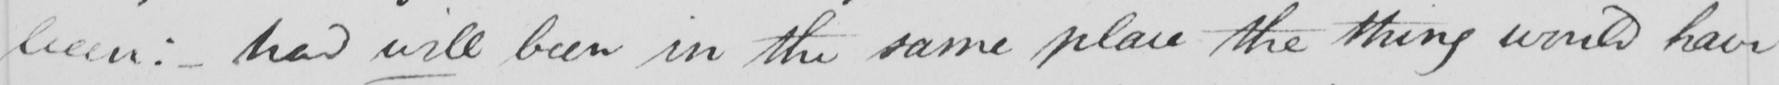Transcribe the text shown in this historical manuscript line. been :   _  had will been in the same place the thing would have 